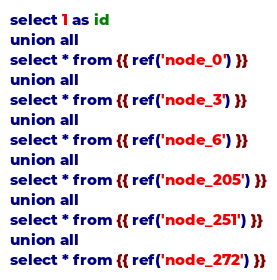Convert code to text. <code><loc_0><loc_0><loc_500><loc_500><_SQL_>select 1 as id
union all
select * from {{ ref('node_0') }}
union all
select * from {{ ref('node_3') }}
union all
select * from {{ ref('node_6') }}
union all
select * from {{ ref('node_205') }}
union all
select * from {{ ref('node_251') }}
union all
select * from {{ ref('node_272') }}
</code> 